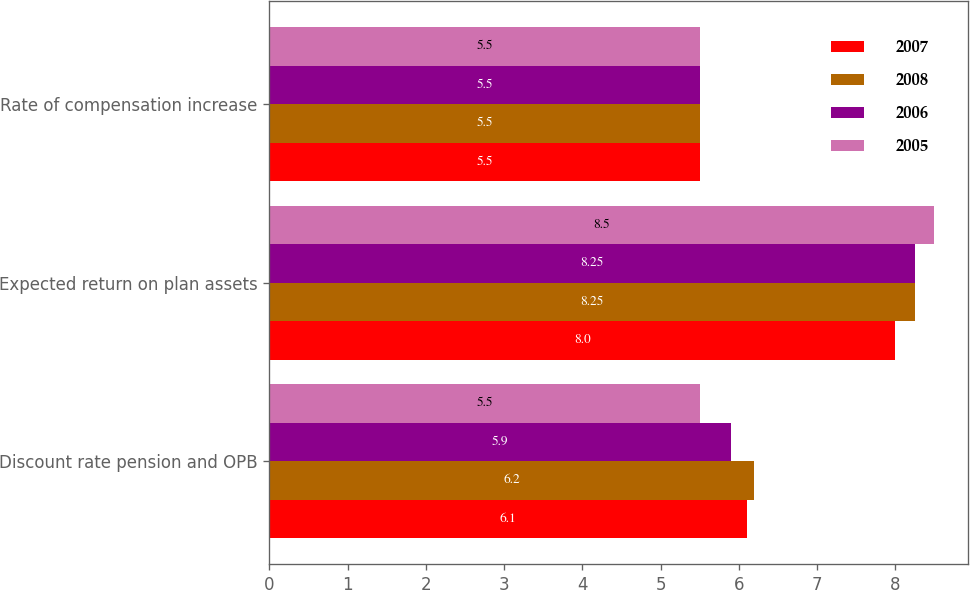Convert chart. <chart><loc_0><loc_0><loc_500><loc_500><stacked_bar_chart><ecel><fcel>Discount rate pension and OPB<fcel>Expected return on plan assets<fcel>Rate of compensation increase<nl><fcel>2007<fcel>6.1<fcel>8<fcel>5.5<nl><fcel>2008<fcel>6.2<fcel>8.25<fcel>5.5<nl><fcel>2006<fcel>5.9<fcel>8.25<fcel>5.5<nl><fcel>2005<fcel>5.5<fcel>8.5<fcel>5.5<nl></chart> 